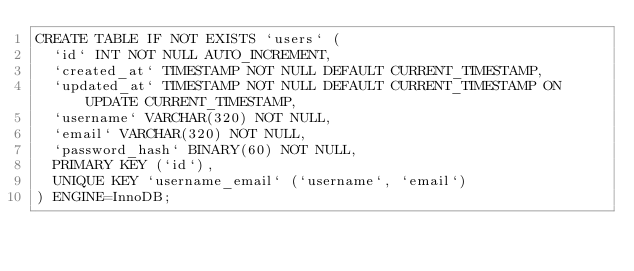<code> <loc_0><loc_0><loc_500><loc_500><_SQL_>CREATE TABLE IF NOT EXISTS `users` (
	`id` INT NOT NULL AUTO_INCREMENT,
	`created_at` TIMESTAMP NOT NULL DEFAULT CURRENT_TIMESTAMP, 
	`updated_at` TIMESTAMP NOT NULL DEFAULT CURRENT_TIMESTAMP ON UPDATE CURRENT_TIMESTAMP,
	`username` VARCHAR(320) NOT NULL,
	`email` VARCHAR(320) NOT NULL,
	`password_hash` BINARY(60) NOT NULL,
	PRIMARY KEY (`id`),
	UNIQUE KEY `username_email` (`username`, `email`)
) ENGINE=InnoDB;	
</code> 